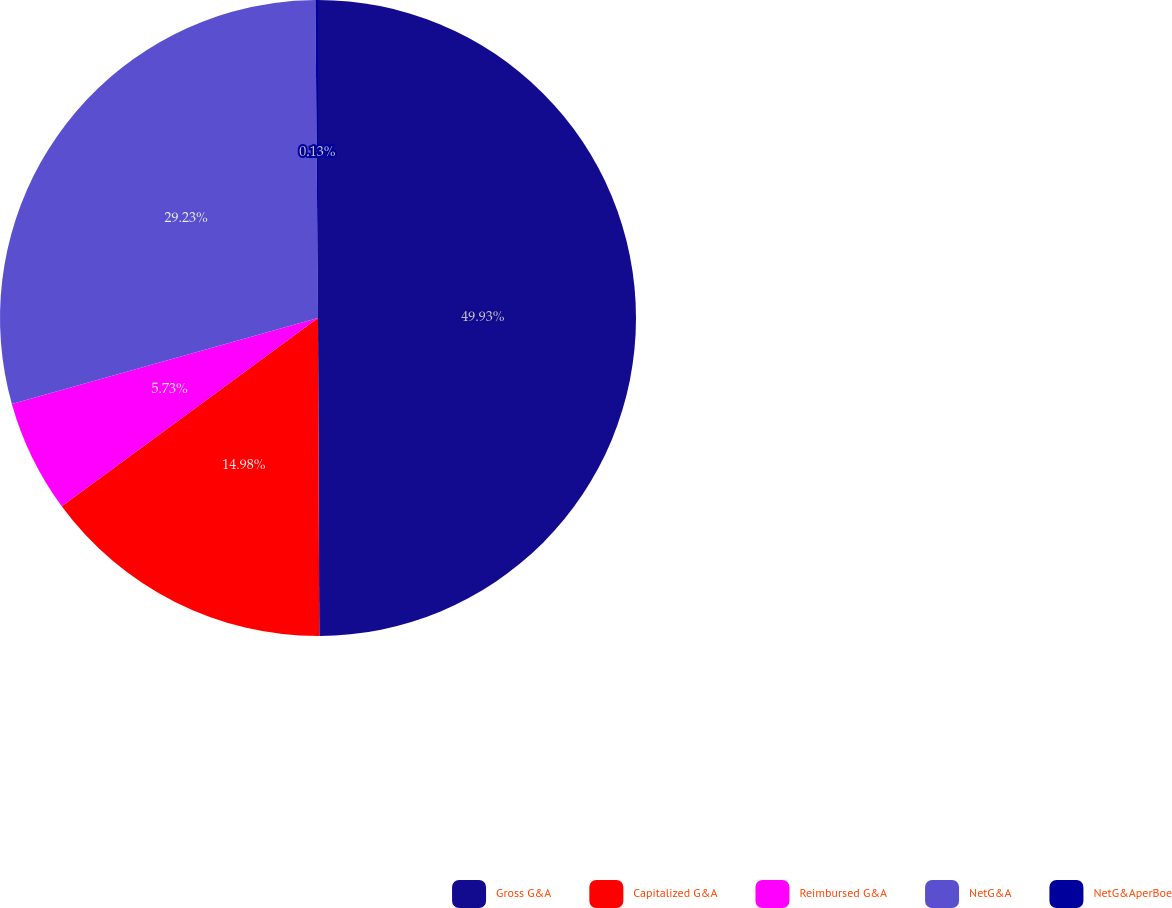Convert chart to OTSL. <chart><loc_0><loc_0><loc_500><loc_500><pie_chart><fcel>Gross G&A<fcel>Capitalized G&A<fcel>Reimbursed G&A<fcel>NetG&A<fcel>NetG&AperBoe<nl><fcel>49.94%<fcel>14.98%<fcel>5.73%<fcel>29.23%<fcel>0.13%<nl></chart> 